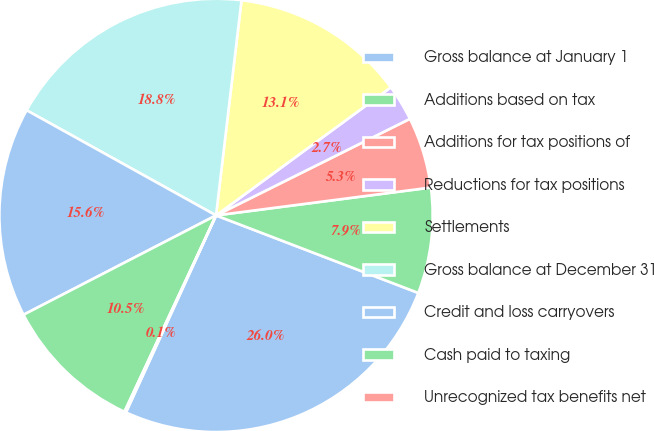Convert chart. <chart><loc_0><loc_0><loc_500><loc_500><pie_chart><fcel>Gross balance at January 1<fcel>Additions based on tax<fcel>Additions for tax positions of<fcel>Reductions for tax positions<fcel>Settlements<fcel>Gross balance at December 31<fcel>Credit and loss carryovers<fcel>Cash paid to taxing<fcel>Unrecognized tax benefits net<nl><fcel>26.0%<fcel>7.88%<fcel>5.3%<fcel>2.71%<fcel>13.06%<fcel>18.81%<fcel>15.65%<fcel>10.47%<fcel>0.12%<nl></chart> 